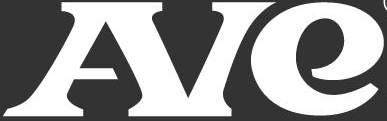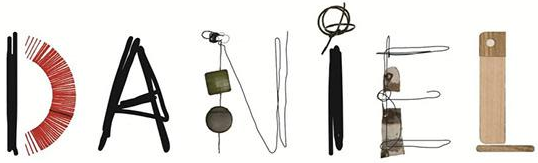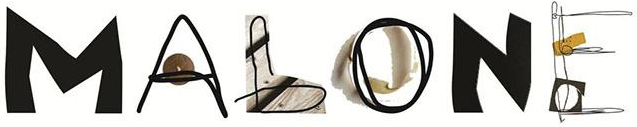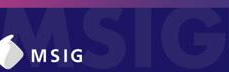What words are shown in these images in order, separated by a semicolon? AIe; DANiEL; MALONE; MSIG 